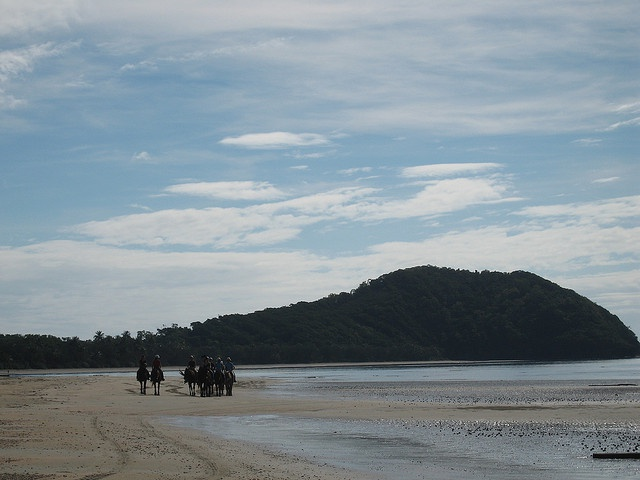Describe the objects in this image and their specific colors. I can see horse in darkgray, black, and gray tones, horse in black, gray, and darkgray tones, horse in black, gray, and darkgray tones, horse in darkgray, black, and gray tones, and people in darkgray, black, and gray tones in this image. 